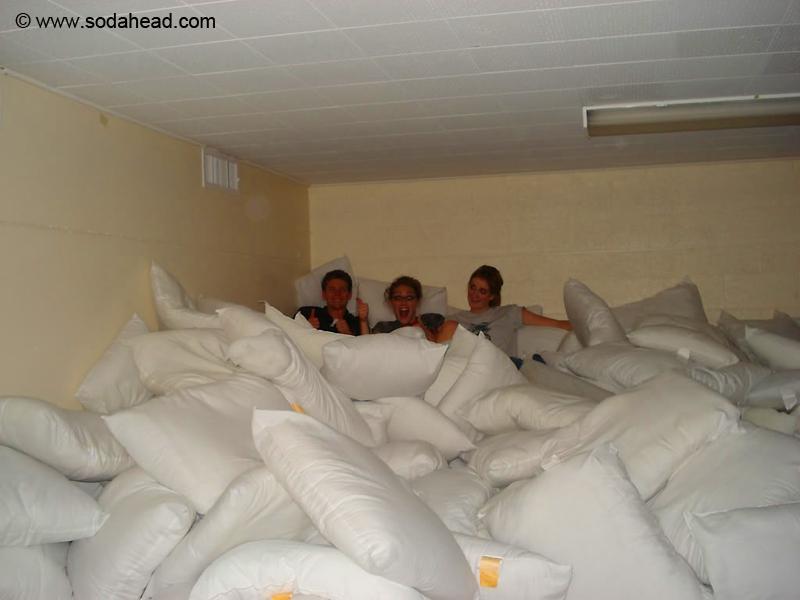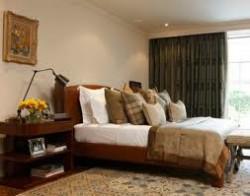The first image is the image on the left, the second image is the image on the right. Considering the images on both sides, is "One image contains at least six full-size all white bed pillows." valid? Answer yes or no. Yes. 